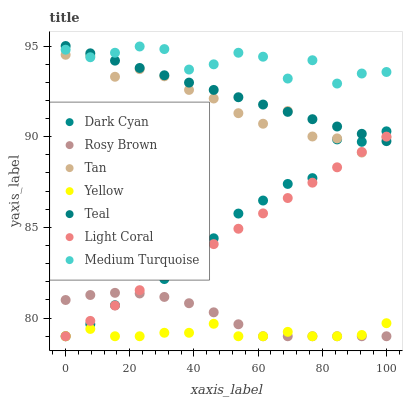Does Yellow have the minimum area under the curve?
Answer yes or no. Yes. Does Medium Turquoise have the maximum area under the curve?
Answer yes or no. Yes. Does Rosy Brown have the minimum area under the curve?
Answer yes or no. No. Does Rosy Brown have the maximum area under the curve?
Answer yes or no. No. Is Teal the smoothest?
Answer yes or no. Yes. Is Medium Turquoise the roughest?
Answer yes or no. Yes. Is Rosy Brown the smoothest?
Answer yes or no. No. Is Rosy Brown the roughest?
Answer yes or no. No. Does Rosy Brown have the lowest value?
Answer yes or no. Yes. Does Teal have the lowest value?
Answer yes or no. No. Does Teal have the highest value?
Answer yes or no. Yes. Does Rosy Brown have the highest value?
Answer yes or no. No. Is Rosy Brown less than Teal?
Answer yes or no. Yes. Is Medium Turquoise greater than Light Coral?
Answer yes or no. Yes. Does Yellow intersect Dark Cyan?
Answer yes or no. Yes. Is Yellow less than Dark Cyan?
Answer yes or no. No. Is Yellow greater than Dark Cyan?
Answer yes or no. No. Does Rosy Brown intersect Teal?
Answer yes or no. No. 